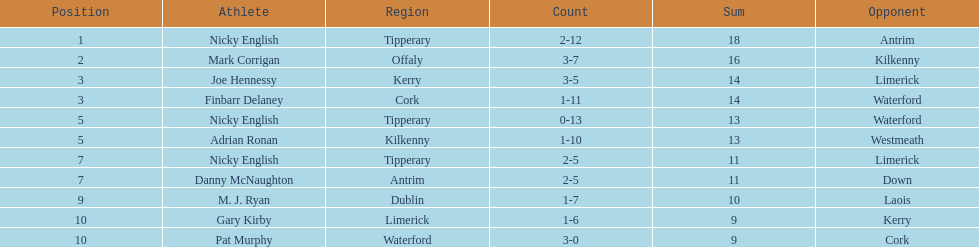Which player ranked the most? Nicky English. 